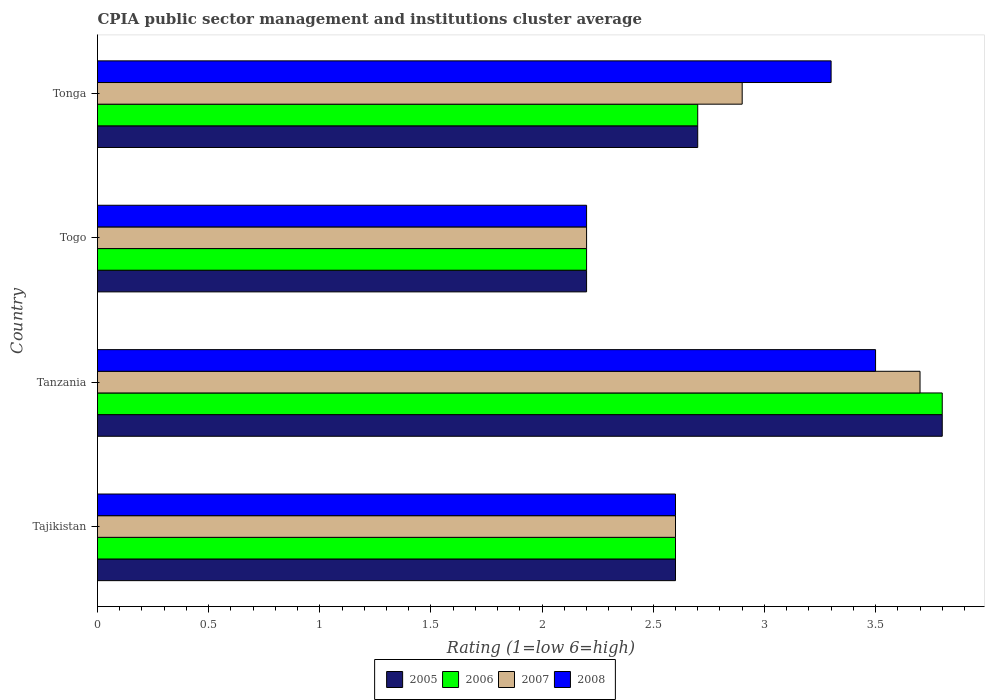Are the number of bars per tick equal to the number of legend labels?
Your answer should be compact. Yes. How many bars are there on the 3rd tick from the top?
Ensure brevity in your answer.  4. What is the label of the 3rd group of bars from the top?
Ensure brevity in your answer.  Tanzania. What is the CPIA rating in 2007 in Tonga?
Provide a short and direct response. 2.9. Across all countries, what is the maximum CPIA rating in 2006?
Make the answer very short. 3.8. In which country was the CPIA rating in 2007 maximum?
Your answer should be compact. Tanzania. In which country was the CPIA rating in 2008 minimum?
Your response must be concise. Togo. What is the total CPIA rating in 2008 in the graph?
Give a very brief answer. 11.6. What is the difference between the CPIA rating in 2006 in Tajikistan and that in Tonga?
Keep it short and to the point. -0.1. What is the difference between the CPIA rating in 2006 in Tajikistan and the CPIA rating in 2005 in Tanzania?
Offer a terse response. -1.2. What is the average CPIA rating in 2008 per country?
Make the answer very short. 2.9. What is the difference between the CPIA rating in 2007 and CPIA rating in 2008 in Tanzania?
Give a very brief answer. 0.2. What is the ratio of the CPIA rating in 2007 in Tajikistan to that in Tanzania?
Provide a short and direct response. 0.7. Is the difference between the CPIA rating in 2007 in Tanzania and Togo greater than the difference between the CPIA rating in 2008 in Tanzania and Togo?
Make the answer very short. Yes. What is the difference between the highest and the second highest CPIA rating in 2006?
Your response must be concise. 1.1. What is the difference between the highest and the lowest CPIA rating in 2006?
Your response must be concise. 1.6. In how many countries, is the CPIA rating in 2005 greater than the average CPIA rating in 2005 taken over all countries?
Make the answer very short. 1. What does the 3rd bar from the top in Tajikistan represents?
Keep it short and to the point. 2006. How many bars are there?
Make the answer very short. 16. Are the values on the major ticks of X-axis written in scientific E-notation?
Make the answer very short. No. Does the graph contain any zero values?
Make the answer very short. No. Does the graph contain grids?
Provide a short and direct response. No. How many legend labels are there?
Your answer should be compact. 4. What is the title of the graph?
Keep it short and to the point. CPIA public sector management and institutions cluster average. What is the label or title of the X-axis?
Your response must be concise. Rating (1=low 6=high). What is the Rating (1=low 6=high) in 2005 in Tajikistan?
Offer a terse response. 2.6. What is the Rating (1=low 6=high) in 2005 in Tanzania?
Provide a succinct answer. 3.8. What is the Rating (1=low 6=high) of 2007 in Togo?
Ensure brevity in your answer.  2.2. What is the Rating (1=low 6=high) of 2005 in Tonga?
Your answer should be compact. 2.7. What is the Rating (1=low 6=high) in 2006 in Tonga?
Give a very brief answer. 2.7. What is the Rating (1=low 6=high) in 2007 in Tonga?
Keep it short and to the point. 2.9. Across all countries, what is the maximum Rating (1=low 6=high) in 2005?
Offer a very short reply. 3.8. Across all countries, what is the maximum Rating (1=low 6=high) of 2008?
Make the answer very short. 3.5. What is the total Rating (1=low 6=high) of 2005 in the graph?
Offer a terse response. 11.3. What is the total Rating (1=low 6=high) in 2006 in the graph?
Make the answer very short. 11.3. What is the total Rating (1=low 6=high) of 2008 in the graph?
Make the answer very short. 11.6. What is the difference between the Rating (1=low 6=high) of 2008 in Tajikistan and that in Tanzania?
Provide a short and direct response. -0.9. What is the difference between the Rating (1=low 6=high) of 2007 in Tajikistan and that in Togo?
Give a very brief answer. 0.4. What is the difference between the Rating (1=low 6=high) in 2006 in Tajikistan and that in Tonga?
Provide a short and direct response. -0.1. What is the difference between the Rating (1=low 6=high) in 2005 in Tanzania and that in Togo?
Provide a short and direct response. 1.6. What is the difference between the Rating (1=low 6=high) of 2006 in Tanzania and that in Togo?
Keep it short and to the point. 1.6. What is the difference between the Rating (1=low 6=high) of 2007 in Tanzania and that in Togo?
Offer a terse response. 1.5. What is the difference between the Rating (1=low 6=high) of 2005 in Tanzania and that in Tonga?
Offer a very short reply. 1.1. What is the difference between the Rating (1=low 6=high) in 2007 in Tanzania and that in Tonga?
Make the answer very short. 0.8. What is the difference between the Rating (1=low 6=high) of 2007 in Togo and that in Tonga?
Provide a succinct answer. -0.7. What is the difference between the Rating (1=low 6=high) in 2008 in Togo and that in Tonga?
Ensure brevity in your answer.  -1.1. What is the difference between the Rating (1=low 6=high) of 2005 in Tajikistan and the Rating (1=low 6=high) of 2008 in Tanzania?
Make the answer very short. -0.9. What is the difference between the Rating (1=low 6=high) of 2006 in Tajikistan and the Rating (1=low 6=high) of 2007 in Tanzania?
Give a very brief answer. -1.1. What is the difference between the Rating (1=low 6=high) of 2006 in Tajikistan and the Rating (1=low 6=high) of 2008 in Tanzania?
Your answer should be very brief. -0.9. What is the difference between the Rating (1=low 6=high) of 2005 in Tajikistan and the Rating (1=low 6=high) of 2007 in Togo?
Offer a terse response. 0.4. What is the difference between the Rating (1=low 6=high) of 2005 in Tajikistan and the Rating (1=low 6=high) of 2008 in Togo?
Ensure brevity in your answer.  0.4. What is the difference between the Rating (1=low 6=high) of 2006 in Tajikistan and the Rating (1=low 6=high) of 2008 in Togo?
Your answer should be very brief. 0.4. What is the difference between the Rating (1=low 6=high) of 2005 in Tajikistan and the Rating (1=low 6=high) of 2006 in Tonga?
Offer a very short reply. -0.1. What is the difference between the Rating (1=low 6=high) in 2006 in Tajikistan and the Rating (1=low 6=high) in 2007 in Tonga?
Provide a short and direct response. -0.3. What is the difference between the Rating (1=low 6=high) in 2005 in Tanzania and the Rating (1=low 6=high) in 2007 in Togo?
Your answer should be very brief. 1.6. What is the difference between the Rating (1=low 6=high) in 2005 in Tanzania and the Rating (1=low 6=high) in 2008 in Togo?
Your answer should be compact. 1.6. What is the difference between the Rating (1=low 6=high) of 2006 in Tanzania and the Rating (1=low 6=high) of 2007 in Togo?
Your answer should be compact. 1.6. What is the difference between the Rating (1=low 6=high) of 2007 in Tanzania and the Rating (1=low 6=high) of 2008 in Togo?
Your response must be concise. 1.5. What is the difference between the Rating (1=low 6=high) in 2007 in Tanzania and the Rating (1=low 6=high) in 2008 in Tonga?
Make the answer very short. 0.4. What is the difference between the Rating (1=low 6=high) of 2005 in Togo and the Rating (1=low 6=high) of 2006 in Tonga?
Your answer should be compact. -0.5. What is the difference between the Rating (1=low 6=high) of 2005 in Togo and the Rating (1=low 6=high) of 2007 in Tonga?
Give a very brief answer. -0.7. What is the difference between the Rating (1=low 6=high) in 2006 in Togo and the Rating (1=low 6=high) in 2007 in Tonga?
Offer a very short reply. -0.7. What is the difference between the Rating (1=low 6=high) in 2007 in Togo and the Rating (1=low 6=high) in 2008 in Tonga?
Provide a succinct answer. -1.1. What is the average Rating (1=low 6=high) of 2005 per country?
Offer a terse response. 2.83. What is the average Rating (1=low 6=high) in 2006 per country?
Give a very brief answer. 2.83. What is the average Rating (1=low 6=high) of 2007 per country?
Provide a short and direct response. 2.85. What is the difference between the Rating (1=low 6=high) of 2005 and Rating (1=low 6=high) of 2006 in Tajikistan?
Ensure brevity in your answer.  0. What is the difference between the Rating (1=low 6=high) in 2006 and Rating (1=low 6=high) in 2007 in Tajikistan?
Offer a terse response. 0. What is the difference between the Rating (1=low 6=high) in 2005 and Rating (1=low 6=high) in 2008 in Tanzania?
Your answer should be very brief. 0.3. What is the difference between the Rating (1=low 6=high) of 2006 and Rating (1=low 6=high) of 2007 in Tanzania?
Your answer should be very brief. 0.1. What is the difference between the Rating (1=low 6=high) in 2005 and Rating (1=low 6=high) in 2007 in Togo?
Ensure brevity in your answer.  0. What is the difference between the Rating (1=low 6=high) in 2006 and Rating (1=low 6=high) in 2007 in Togo?
Give a very brief answer. 0. What is the difference between the Rating (1=low 6=high) of 2006 and Rating (1=low 6=high) of 2008 in Togo?
Provide a short and direct response. 0. What is the difference between the Rating (1=low 6=high) in 2007 and Rating (1=low 6=high) in 2008 in Togo?
Make the answer very short. 0. What is the difference between the Rating (1=low 6=high) of 2005 and Rating (1=low 6=high) of 2007 in Tonga?
Provide a short and direct response. -0.2. What is the difference between the Rating (1=low 6=high) of 2006 and Rating (1=low 6=high) of 2007 in Tonga?
Offer a very short reply. -0.2. What is the difference between the Rating (1=low 6=high) of 2006 and Rating (1=low 6=high) of 2008 in Tonga?
Ensure brevity in your answer.  -0.6. What is the difference between the Rating (1=low 6=high) of 2007 and Rating (1=low 6=high) of 2008 in Tonga?
Your answer should be very brief. -0.4. What is the ratio of the Rating (1=low 6=high) of 2005 in Tajikistan to that in Tanzania?
Provide a short and direct response. 0.68. What is the ratio of the Rating (1=low 6=high) in 2006 in Tajikistan to that in Tanzania?
Offer a terse response. 0.68. What is the ratio of the Rating (1=low 6=high) in 2007 in Tajikistan to that in Tanzania?
Ensure brevity in your answer.  0.7. What is the ratio of the Rating (1=low 6=high) of 2008 in Tajikistan to that in Tanzania?
Provide a succinct answer. 0.74. What is the ratio of the Rating (1=low 6=high) of 2005 in Tajikistan to that in Togo?
Your answer should be very brief. 1.18. What is the ratio of the Rating (1=low 6=high) in 2006 in Tajikistan to that in Togo?
Keep it short and to the point. 1.18. What is the ratio of the Rating (1=low 6=high) of 2007 in Tajikistan to that in Togo?
Keep it short and to the point. 1.18. What is the ratio of the Rating (1=low 6=high) of 2008 in Tajikistan to that in Togo?
Offer a terse response. 1.18. What is the ratio of the Rating (1=low 6=high) in 2005 in Tajikistan to that in Tonga?
Your answer should be very brief. 0.96. What is the ratio of the Rating (1=low 6=high) in 2006 in Tajikistan to that in Tonga?
Your answer should be very brief. 0.96. What is the ratio of the Rating (1=low 6=high) of 2007 in Tajikistan to that in Tonga?
Your response must be concise. 0.9. What is the ratio of the Rating (1=low 6=high) of 2008 in Tajikistan to that in Tonga?
Provide a succinct answer. 0.79. What is the ratio of the Rating (1=low 6=high) of 2005 in Tanzania to that in Togo?
Give a very brief answer. 1.73. What is the ratio of the Rating (1=low 6=high) of 2006 in Tanzania to that in Togo?
Your response must be concise. 1.73. What is the ratio of the Rating (1=low 6=high) of 2007 in Tanzania to that in Togo?
Offer a very short reply. 1.68. What is the ratio of the Rating (1=low 6=high) in 2008 in Tanzania to that in Togo?
Offer a very short reply. 1.59. What is the ratio of the Rating (1=low 6=high) of 2005 in Tanzania to that in Tonga?
Your answer should be very brief. 1.41. What is the ratio of the Rating (1=low 6=high) in 2006 in Tanzania to that in Tonga?
Keep it short and to the point. 1.41. What is the ratio of the Rating (1=low 6=high) of 2007 in Tanzania to that in Tonga?
Ensure brevity in your answer.  1.28. What is the ratio of the Rating (1=low 6=high) in 2008 in Tanzania to that in Tonga?
Ensure brevity in your answer.  1.06. What is the ratio of the Rating (1=low 6=high) of 2005 in Togo to that in Tonga?
Keep it short and to the point. 0.81. What is the ratio of the Rating (1=low 6=high) of 2006 in Togo to that in Tonga?
Provide a short and direct response. 0.81. What is the ratio of the Rating (1=low 6=high) in 2007 in Togo to that in Tonga?
Make the answer very short. 0.76. What is the ratio of the Rating (1=low 6=high) of 2008 in Togo to that in Tonga?
Ensure brevity in your answer.  0.67. What is the difference between the highest and the second highest Rating (1=low 6=high) of 2006?
Give a very brief answer. 1.1. What is the difference between the highest and the second highest Rating (1=low 6=high) of 2007?
Offer a very short reply. 0.8. What is the difference between the highest and the second highest Rating (1=low 6=high) in 2008?
Your response must be concise. 0.2. What is the difference between the highest and the lowest Rating (1=low 6=high) in 2005?
Offer a terse response. 1.6. What is the difference between the highest and the lowest Rating (1=low 6=high) of 2006?
Make the answer very short. 1.6. What is the difference between the highest and the lowest Rating (1=low 6=high) of 2007?
Your answer should be compact. 1.5. 